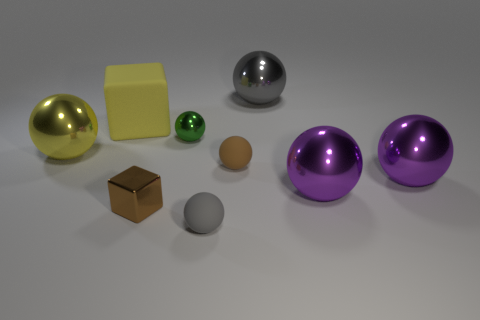Subtract all green balls. How many balls are left? 6 Subtract all large gray metallic spheres. How many spheres are left? 6 Subtract all gray spheres. Subtract all blue cylinders. How many spheres are left? 5 Subtract all blocks. How many objects are left? 7 Subtract all gray rubber objects. Subtract all tiny cyan cubes. How many objects are left? 8 Add 1 rubber objects. How many rubber objects are left? 4 Add 2 brown rubber cubes. How many brown rubber cubes exist? 2 Subtract 0 cyan spheres. How many objects are left? 9 